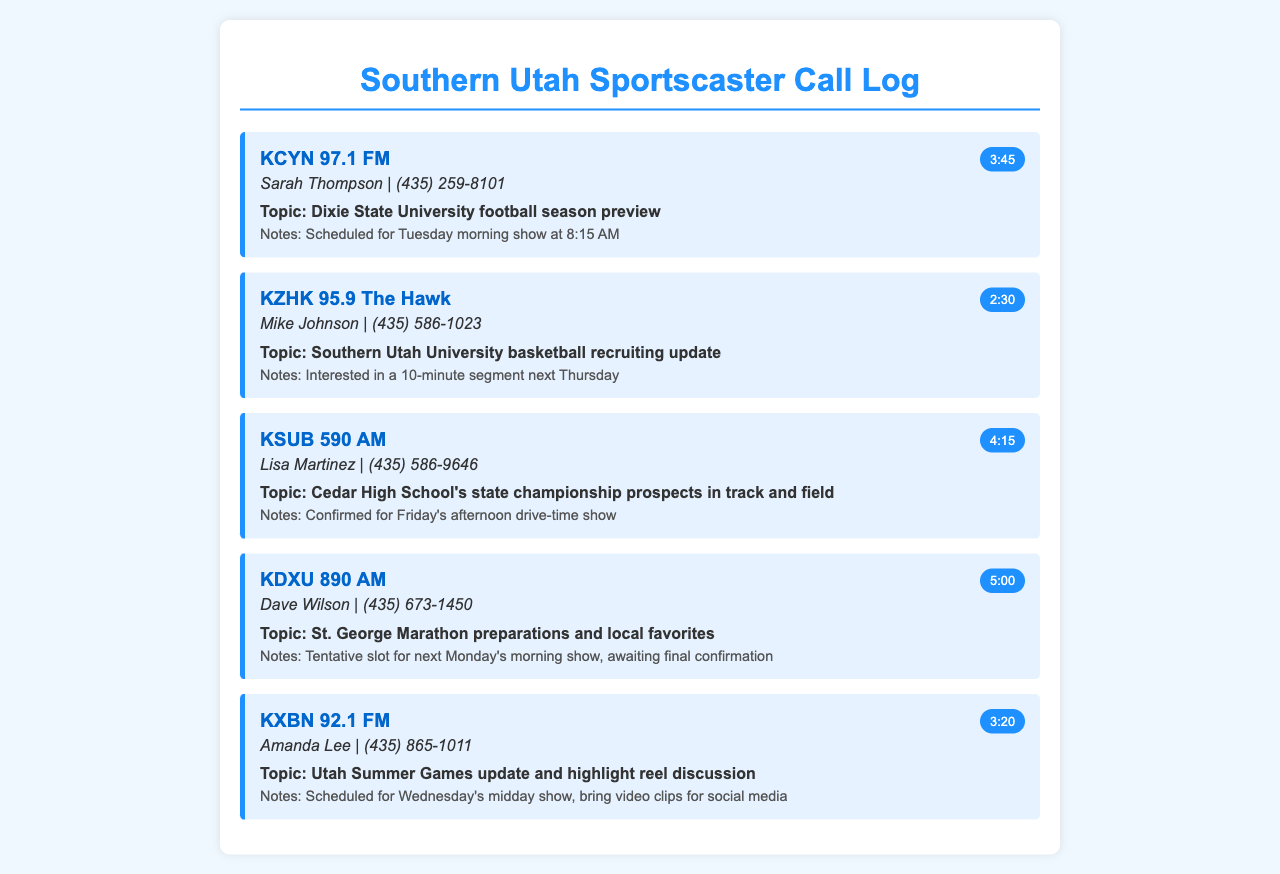What is the duration of the call to KCYN 97.1 FM? The duration of the call is specified in the document, which states it lasted for 3 minutes and 45 seconds.
Answer: 3:45 Who did the call to KZHK 95.9 The Hawk? The document provides the contact information for this call, showing that it was made to Mike Johnson.
Answer: Mike Johnson What topic was discussed during the call to KSUB 590 AM? The document includes the topic mentioned for this call, which was about Cedar High School's state championship in track and field.
Answer: Cedar High School's state championship prospects in track and field When is the guest scheduled for KXBN 92.1 FM? Details in the document reveal that the scheduled time for the guest appearance is on Wednesday's midday show.
Answer: Wednesday's midday show How long is the segment requested by KZHK 95.9 The Hawk? The document notes that they were interested in a 10-minute segment.
Answer: 10 minutes Which radio station is awaiting final confirmation for the guest appearance? The document indicates that KDXU 890 AM is the station awaiting final confirmation for the guest appearance.
Answer: KDXU 890 AM What is the name of the contact person for KCYN 97.1 FM? The document lists the contact person for this station as Sarah Thompson.
Answer: Sarah Thompson What is the scheduled time for the Dixie State University football season preview? The document specifies that the preview is scheduled for Tuesday morning at 8:15 AM.
Answer: Tuesday morning at 8:15 AM 